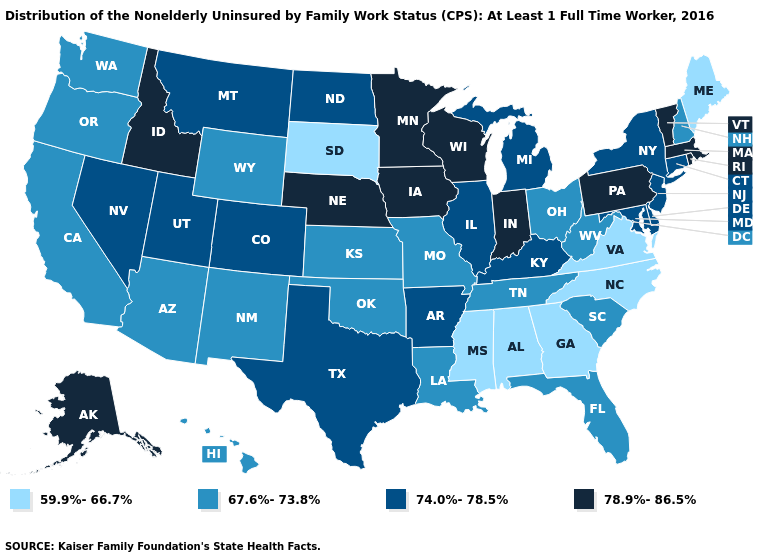Name the states that have a value in the range 74.0%-78.5%?
Concise answer only. Arkansas, Colorado, Connecticut, Delaware, Illinois, Kentucky, Maryland, Michigan, Montana, Nevada, New Jersey, New York, North Dakota, Texas, Utah. Among the states that border South Dakota , which have the highest value?
Give a very brief answer. Iowa, Minnesota, Nebraska. What is the lowest value in states that border New Hampshire?
Write a very short answer. 59.9%-66.7%. Name the states that have a value in the range 78.9%-86.5%?
Give a very brief answer. Alaska, Idaho, Indiana, Iowa, Massachusetts, Minnesota, Nebraska, Pennsylvania, Rhode Island, Vermont, Wisconsin. Among the states that border Mississippi , does Alabama have the highest value?
Answer briefly. No. Name the states that have a value in the range 67.6%-73.8%?
Be succinct. Arizona, California, Florida, Hawaii, Kansas, Louisiana, Missouri, New Hampshire, New Mexico, Ohio, Oklahoma, Oregon, South Carolina, Tennessee, Washington, West Virginia, Wyoming. Among the states that border New York , which have the highest value?
Give a very brief answer. Massachusetts, Pennsylvania, Vermont. Which states have the lowest value in the USA?
Give a very brief answer. Alabama, Georgia, Maine, Mississippi, North Carolina, South Dakota, Virginia. What is the highest value in the USA?
Be succinct. 78.9%-86.5%. Among the states that border Indiana , which have the highest value?
Short answer required. Illinois, Kentucky, Michigan. Which states have the highest value in the USA?
Give a very brief answer. Alaska, Idaho, Indiana, Iowa, Massachusetts, Minnesota, Nebraska, Pennsylvania, Rhode Island, Vermont, Wisconsin. Name the states that have a value in the range 67.6%-73.8%?
Concise answer only. Arizona, California, Florida, Hawaii, Kansas, Louisiana, Missouri, New Hampshire, New Mexico, Ohio, Oklahoma, Oregon, South Carolina, Tennessee, Washington, West Virginia, Wyoming. What is the value of Missouri?
Keep it brief. 67.6%-73.8%. What is the value of New Jersey?
Quick response, please. 74.0%-78.5%. Does North Carolina have the highest value in the USA?
Concise answer only. No. 